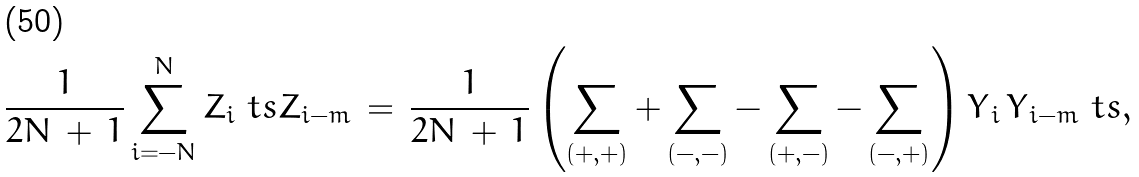Convert formula to latex. <formula><loc_0><loc_0><loc_500><loc_500>\frac { 1 } { 2 N \, + \, 1 } \sum _ { i = - N } ^ { N } Z _ { i } \ t s Z _ { i - m } \, = \, \frac { 1 } { 2 N \, + \, 1 } \left ( \sum _ { ( + , + ) } + \sum _ { ( - , - ) } - \sum _ { ( + , - ) } - \sum _ { ( - , + ) } \right ) Y _ { \, i } \, Y _ { \, i - m } \ t s ,</formula> 